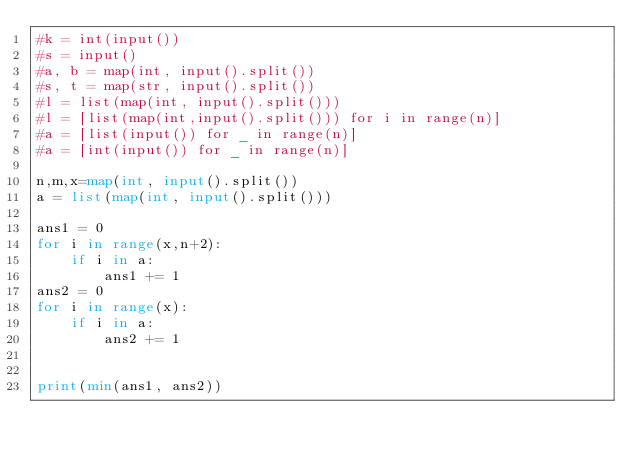Convert code to text. <code><loc_0><loc_0><loc_500><loc_500><_Python_>#k = int(input())
#s = input()
#a, b = map(int, input().split())
#s, t = map(str, input().split())
#l = list(map(int, input().split()))
#l = [list(map(int,input().split())) for i in range(n)]
#a = [list(input()) for _ in range(n)]
#a = [int(input()) for _ in range(n)]

n,m,x=map(int, input().split())
a = list(map(int, input().split()))

ans1 = 0
for i in range(x,n+2):
    if i in a:
        ans1 += 1
ans2 = 0
for i in range(x):
    if i in a:
        ans2 += 1


print(min(ans1, ans2))



</code> 